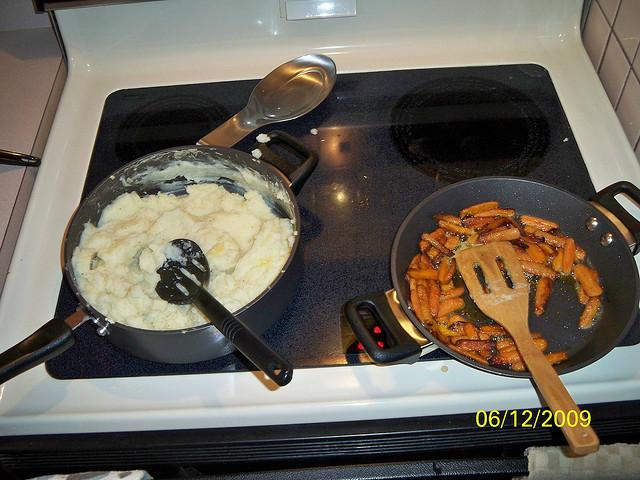What is the silver object above the mashed potatoes pan used for? Please explain your reasoning. spoon rest. A flat object with a depression in it is on the stove. 